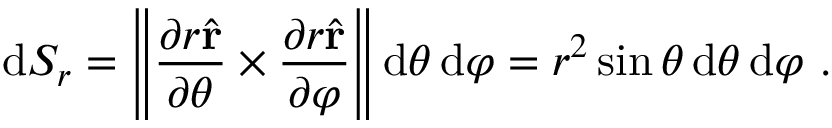Convert formula to latex. <formula><loc_0><loc_0><loc_500><loc_500>d S _ { r } = \left \| { \frac { \partial r { \hat { r } } } { \partial \theta } } \times { \frac { \partial r { \hat { r } } } { \partial \varphi } } \right \| d \theta \, d \varphi = r ^ { 2 } \sin \theta \, d \theta \, d \varphi .</formula> 